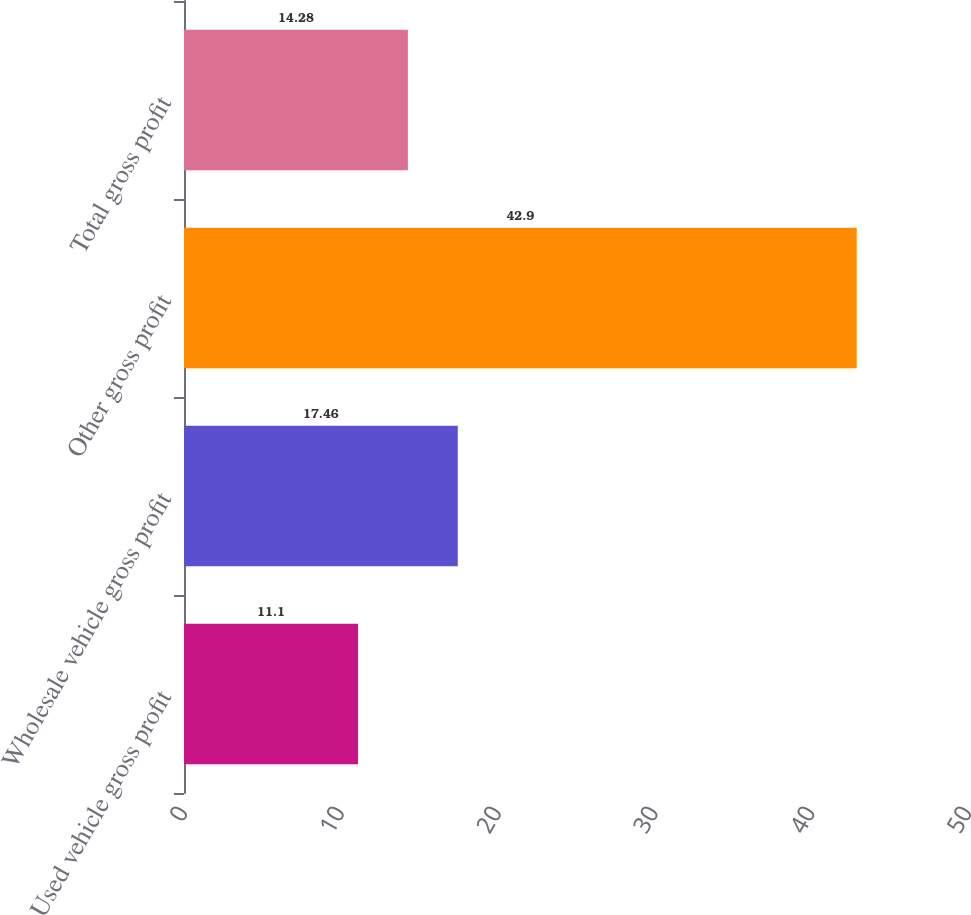Convert chart. <chart><loc_0><loc_0><loc_500><loc_500><bar_chart><fcel>Used vehicle gross profit<fcel>Wholesale vehicle gross profit<fcel>Other gross profit<fcel>Total gross profit<nl><fcel>11.1<fcel>17.46<fcel>42.9<fcel>14.28<nl></chart> 